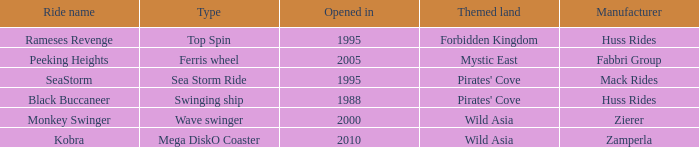What ride was manufactured by Zierer? Monkey Swinger. 